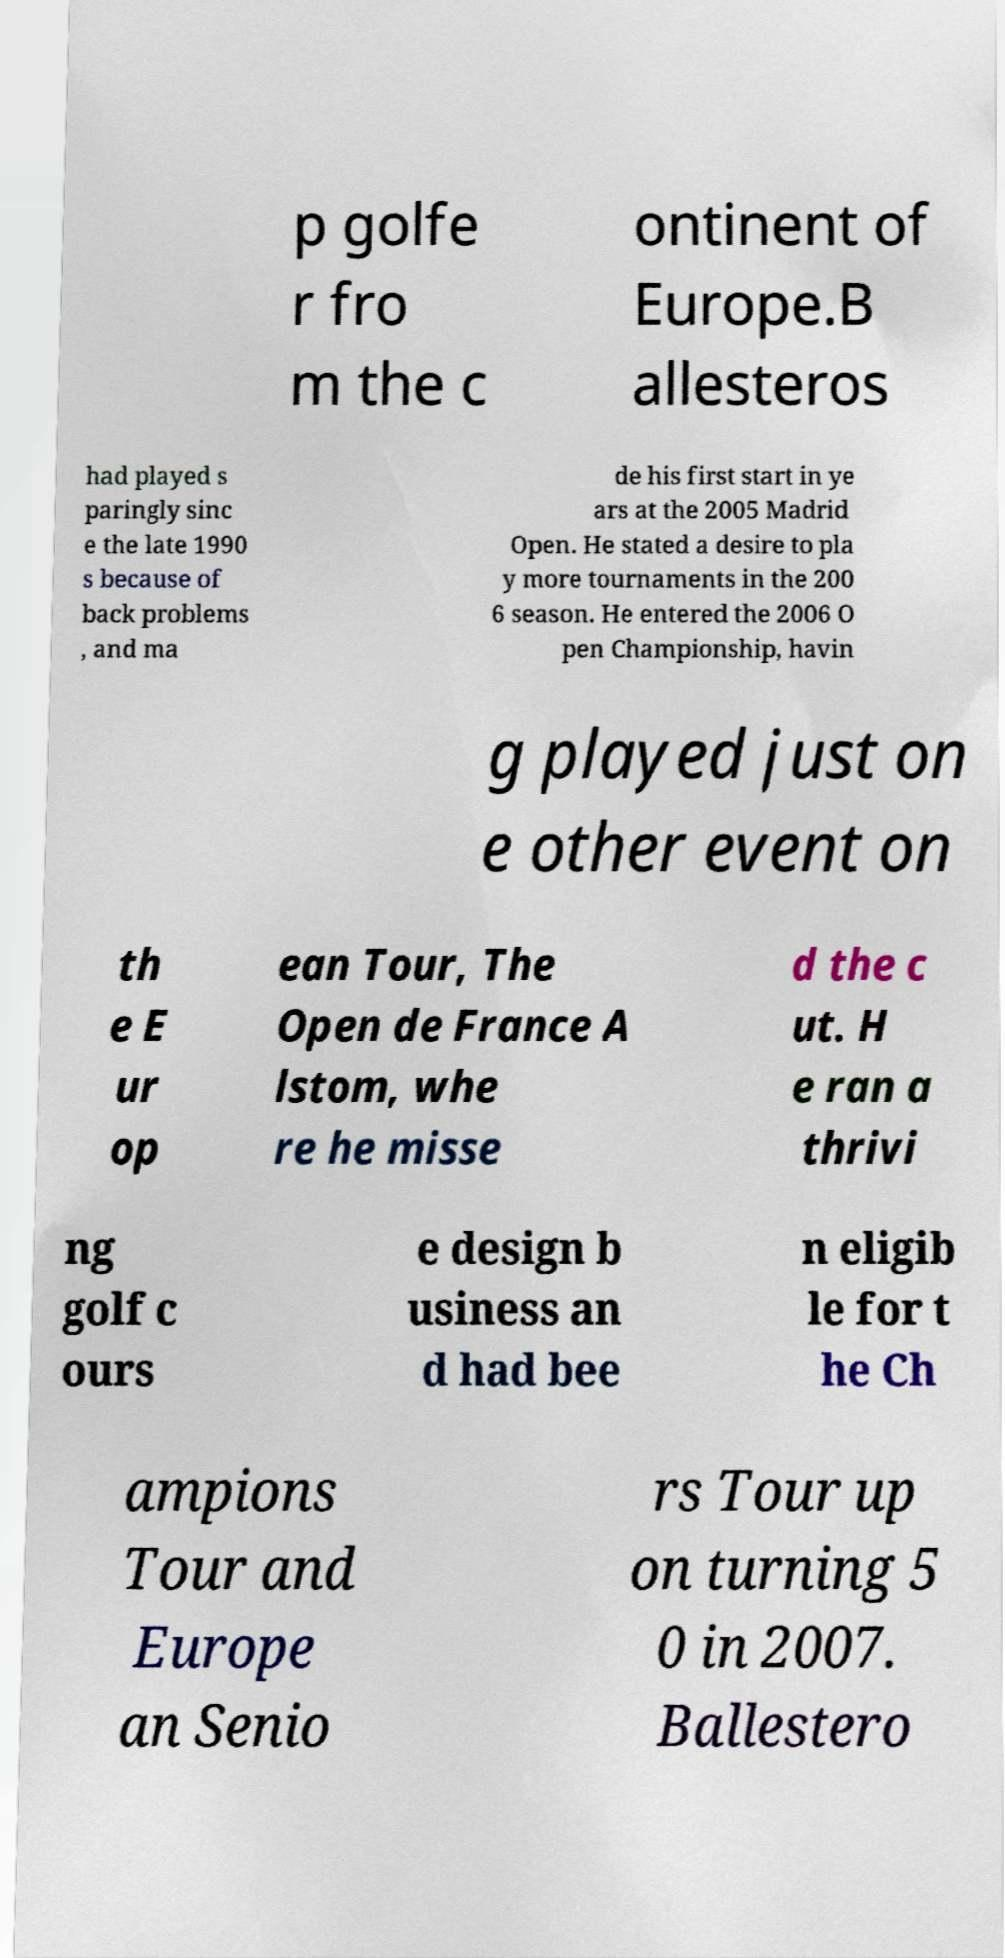Can you read and provide the text displayed in the image?This photo seems to have some interesting text. Can you extract and type it out for me? p golfe r fro m the c ontinent of Europe.B allesteros had played s paringly sinc e the late 1990 s because of back problems , and ma de his first start in ye ars at the 2005 Madrid Open. He stated a desire to pla y more tournaments in the 200 6 season. He entered the 2006 O pen Championship, havin g played just on e other event on th e E ur op ean Tour, The Open de France A lstom, whe re he misse d the c ut. H e ran a thrivi ng golf c ours e design b usiness an d had bee n eligib le for t he Ch ampions Tour and Europe an Senio rs Tour up on turning 5 0 in 2007. Ballestero 